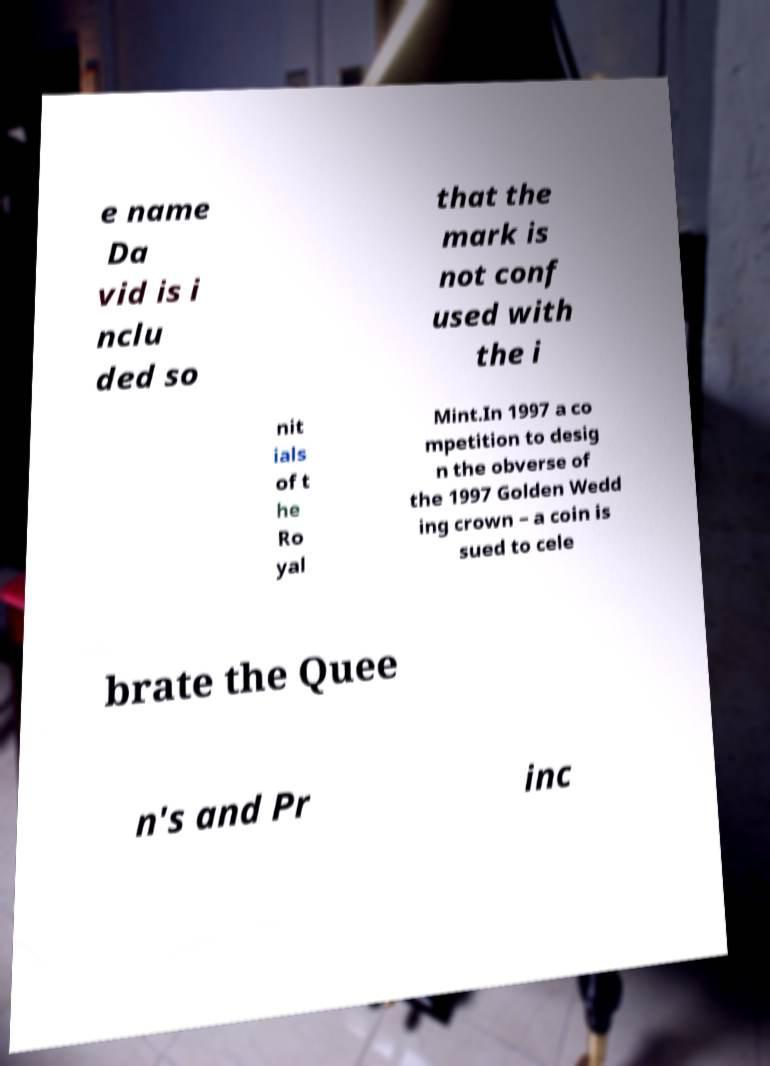There's text embedded in this image that I need extracted. Can you transcribe it verbatim? e name Da vid is i nclu ded so that the mark is not conf used with the i nit ials of t he Ro yal Mint.In 1997 a co mpetition to desig n the obverse of the 1997 Golden Wedd ing crown – a coin is sued to cele brate the Quee n's and Pr inc 